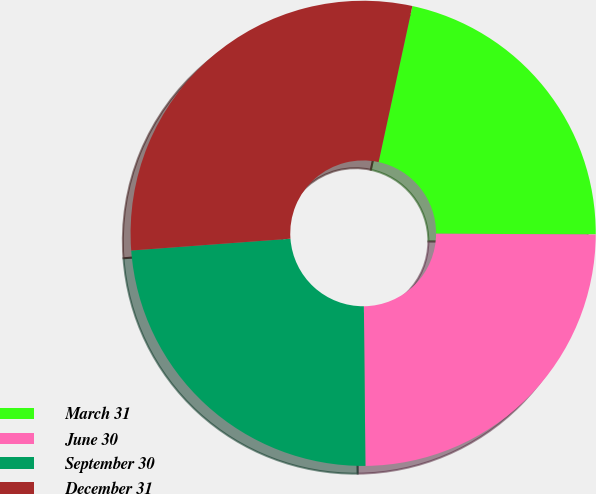Convert chart. <chart><loc_0><loc_0><loc_500><loc_500><pie_chart><fcel>March 31<fcel>June 30<fcel>September 30<fcel>December 31<nl><fcel>21.68%<fcel>24.77%<fcel>23.98%<fcel>29.57%<nl></chart> 